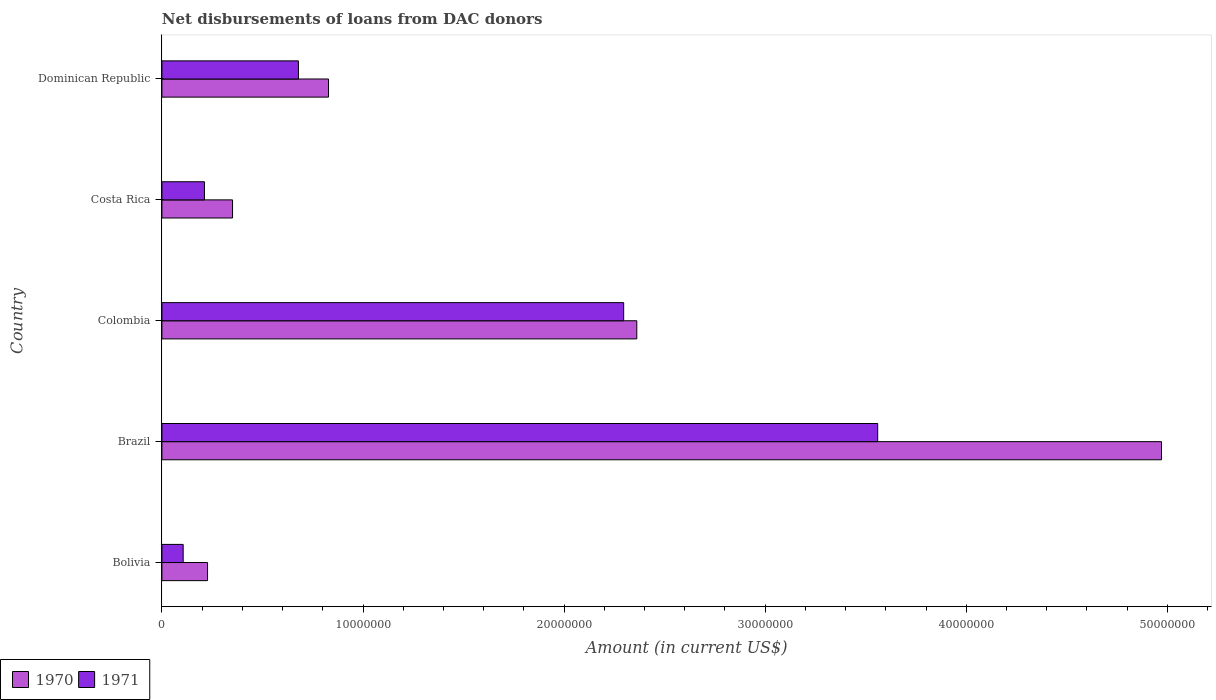How many groups of bars are there?
Give a very brief answer. 5. Are the number of bars per tick equal to the number of legend labels?
Keep it short and to the point. Yes. How many bars are there on the 2nd tick from the bottom?
Give a very brief answer. 2. What is the label of the 5th group of bars from the top?
Provide a succinct answer. Bolivia. What is the amount of loans disbursed in 1970 in Colombia?
Give a very brief answer. 2.36e+07. Across all countries, what is the maximum amount of loans disbursed in 1971?
Give a very brief answer. 3.56e+07. Across all countries, what is the minimum amount of loans disbursed in 1971?
Ensure brevity in your answer.  1.06e+06. In which country was the amount of loans disbursed in 1970 minimum?
Offer a terse response. Bolivia. What is the total amount of loans disbursed in 1971 in the graph?
Offer a very short reply. 6.85e+07. What is the difference between the amount of loans disbursed in 1971 in Brazil and that in Colombia?
Offer a terse response. 1.26e+07. What is the difference between the amount of loans disbursed in 1971 in Costa Rica and the amount of loans disbursed in 1970 in Brazil?
Your answer should be compact. -4.76e+07. What is the average amount of loans disbursed in 1971 per country?
Provide a succinct answer. 1.37e+07. What is the difference between the amount of loans disbursed in 1970 and amount of loans disbursed in 1971 in Colombia?
Keep it short and to the point. 6.52e+05. In how many countries, is the amount of loans disbursed in 1971 greater than 12000000 US$?
Your response must be concise. 2. What is the ratio of the amount of loans disbursed in 1970 in Colombia to that in Dominican Republic?
Keep it short and to the point. 2.85. What is the difference between the highest and the second highest amount of loans disbursed in 1971?
Provide a succinct answer. 1.26e+07. What is the difference between the highest and the lowest amount of loans disbursed in 1971?
Your answer should be very brief. 3.45e+07. What does the 2nd bar from the top in Bolivia represents?
Give a very brief answer. 1970. What is the difference between two consecutive major ticks on the X-axis?
Your response must be concise. 1.00e+07. Are the values on the major ticks of X-axis written in scientific E-notation?
Give a very brief answer. No. Does the graph contain grids?
Provide a succinct answer. No. How are the legend labels stacked?
Your answer should be compact. Horizontal. What is the title of the graph?
Your answer should be compact. Net disbursements of loans from DAC donors. What is the Amount (in current US$) in 1970 in Bolivia?
Provide a short and direct response. 2.27e+06. What is the Amount (in current US$) in 1971 in Bolivia?
Make the answer very short. 1.06e+06. What is the Amount (in current US$) in 1970 in Brazil?
Provide a succinct answer. 4.97e+07. What is the Amount (in current US$) of 1971 in Brazil?
Provide a short and direct response. 3.56e+07. What is the Amount (in current US$) of 1970 in Colombia?
Your answer should be compact. 2.36e+07. What is the Amount (in current US$) in 1971 in Colombia?
Your answer should be compact. 2.30e+07. What is the Amount (in current US$) of 1970 in Costa Rica?
Provide a short and direct response. 3.51e+06. What is the Amount (in current US$) of 1971 in Costa Rica?
Keep it short and to the point. 2.12e+06. What is the Amount (in current US$) in 1970 in Dominican Republic?
Provide a succinct answer. 8.29e+06. What is the Amount (in current US$) of 1971 in Dominican Republic?
Your response must be concise. 6.79e+06. Across all countries, what is the maximum Amount (in current US$) of 1970?
Provide a short and direct response. 4.97e+07. Across all countries, what is the maximum Amount (in current US$) of 1971?
Ensure brevity in your answer.  3.56e+07. Across all countries, what is the minimum Amount (in current US$) in 1970?
Your answer should be very brief. 2.27e+06. Across all countries, what is the minimum Amount (in current US$) of 1971?
Ensure brevity in your answer.  1.06e+06. What is the total Amount (in current US$) of 1970 in the graph?
Make the answer very short. 8.74e+07. What is the total Amount (in current US$) of 1971 in the graph?
Keep it short and to the point. 6.85e+07. What is the difference between the Amount (in current US$) in 1970 in Bolivia and that in Brazil?
Provide a short and direct response. -4.74e+07. What is the difference between the Amount (in current US$) of 1971 in Bolivia and that in Brazil?
Your response must be concise. -3.45e+07. What is the difference between the Amount (in current US$) in 1970 in Bolivia and that in Colombia?
Offer a terse response. -2.13e+07. What is the difference between the Amount (in current US$) in 1971 in Bolivia and that in Colombia?
Keep it short and to the point. -2.19e+07. What is the difference between the Amount (in current US$) in 1970 in Bolivia and that in Costa Rica?
Keep it short and to the point. -1.24e+06. What is the difference between the Amount (in current US$) of 1971 in Bolivia and that in Costa Rica?
Offer a very short reply. -1.06e+06. What is the difference between the Amount (in current US$) of 1970 in Bolivia and that in Dominican Republic?
Offer a terse response. -6.02e+06. What is the difference between the Amount (in current US$) of 1971 in Bolivia and that in Dominican Republic?
Your response must be concise. -5.73e+06. What is the difference between the Amount (in current US$) of 1970 in Brazil and that in Colombia?
Provide a succinct answer. 2.61e+07. What is the difference between the Amount (in current US$) of 1971 in Brazil and that in Colombia?
Provide a short and direct response. 1.26e+07. What is the difference between the Amount (in current US$) of 1970 in Brazil and that in Costa Rica?
Give a very brief answer. 4.62e+07. What is the difference between the Amount (in current US$) in 1971 in Brazil and that in Costa Rica?
Your answer should be very brief. 3.35e+07. What is the difference between the Amount (in current US$) of 1970 in Brazil and that in Dominican Republic?
Give a very brief answer. 4.14e+07. What is the difference between the Amount (in current US$) in 1971 in Brazil and that in Dominican Republic?
Your answer should be very brief. 2.88e+07. What is the difference between the Amount (in current US$) of 1970 in Colombia and that in Costa Rica?
Give a very brief answer. 2.01e+07. What is the difference between the Amount (in current US$) in 1971 in Colombia and that in Costa Rica?
Give a very brief answer. 2.08e+07. What is the difference between the Amount (in current US$) in 1970 in Colombia and that in Dominican Republic?
Your answer should be very brief. 1.53e+07. What is the difference between the Amount (in current US$) in 1971 in Colombia and that in Dominican Republic?
Keep it short and to the point. 1.62e+07. What is the difference between the Amount (in current US$) in 1970 in Costa Rica and that in Dominican Republic?
Give a very brief answer. -4.77e+06. What is the difference between the Amount (in current US$) in 1971 in Costa Rica and that in Dominican Republic?
Offer a very short reply. -4.67e+06. What is the difference between the Amount (in current US$) in 1970 in Bolivia and the Amount (in current US$) in 1971 in Brazil?
Ensure brevity in your answer.  -3.33e+07. What is the difference between the Amount (in current US$) in 1970 in Bolivia and the Amount (in current US$) in 1971 in Colombia?
Make the answer very short. -2.07e+07. What is the difference between the Amount (in current US$) in 1970 in Bolivia and the Amount (in current US$) in 1971 in Costa Rica?
Provide a short and direct response. 1.54e+05. What is the difference between the Amount (in current US$) of 1970 in Bolivia and the Amount (in current US$) of 1971 in Dominican Republic?
Offer a very short reply. -4.52e+06. What is the difference between the Amount (in current US$) of 1970 in Brazil and the Amount (in current US$) of 1971 in Colombia?
Ensure brevity in your answer.  2.67e+07. What is the difference between the Amount (in current US$) of 1970 in Brazil and the Amount (in current US$) of 1971 in Costa Rica?
Give a very brief answer. 4.76e+07. What is the difference between the Amount (in current US$) in 1970 in Brazil and the Amount (in current US$) in 1971 in Dominican Republic?
Give a very brief answer. 4.29e+07. What is the difference between the Amount (in current US$) in 1970 in Colombia and the Amount (in current US$) in 1971 in Costa Rica?
Provide a succinct answer. 2.15e+07. What is the difference between the Amount (in current US$) of 1970 in Colombia and the Amount (in current US$) of 1971 in Dominican Republic?
Offer a terse response. 1.68e+07. What is the difference between the Amount (in current US$) in 1970 in Costa Rica and the Amount (in current US$) in 1971 in Dominican Republic?
Your answer should be very brief. -3.28e+06. What is the average Amount (in current US$) in 1970 per country?
Ensure brevity in your answer.  1.75e+07. What is the average Amount (in current US$) of 1971 per country?
Your answer should be compact. 1.37e+07. What is the difference between the Amount (in current US$) in 1970 and Amount (in current US$) in 1971 in Bolivia?
Offer a terse response. 1.21e+06. What is the difference between the Amount (in current US$) of 1970 and Amount (in current US$) of 1971 in Brazil?
Make the answer very short. 1.41e+07. What is the difference between the Amount (in current US$) of 1970 and Amount (in current US$) of 1971 in Colombia?
Offer a terse response. 6.52e+05. What is the difference between the Amount (in current US$) in 1970 and Amount (in current US$) in 1971 in Costa Rica?
Your answer should be very brief. 1.40e+06. What is the difference between the Amount (in current US$) in 1970 and Amount (in current US$) in 1971 in Dominican Republic?
Keep it short and to the point. 1.50e+06. What is the ratio of the Amount (in current US$) in 1970 in Bolivia to that in Brazil?
Provide a short and direct response. 0.05. What is the ratio of the Amount (in current US$) in 1971 in Bolivia to that in Brazil?
Give a very brief answer. 0.03. What is the ratio of the Amount (in current US$) in 1970 in Bolivia to that in Colombia?
Your answer should be compact. 0.1. What is the ratio of the Amount (in current US$) of 1971 in Bolivia to that in Colombia?
Provide a succinct answer. 0.05. What is the ratio of the Amount (in current US$) of 1970 in Bolivia to that in Costa Rica?
Your answer should be compact. 0.65. What is the ratio of the Amount (in current US$) of 1971 in Bolivia to that in Costa Rica?
Offer a terse response. 0.5. What is the ratio of the Amount (in current US$) of 1970 in Bolivia to that in Dominican Republic?
Provide a succinct answer. 0.27. What is the ratio of the Amount (in current US$) of 1971 in Bolivia to that in Dominican Republic?
Offer a terse response. 0.16. What is the ratio of the Amount (in current US$) in 1970 in Brazil to that in Colombia?
Provide a succinct answer. 2.1. What is the ratio of the Amount (in current US$) of 1971 in Brazil to that in Colombia?
Your response must be concise. 1.55. What is the ratio of the Amount (in current US$) of 1970 in Brazil to that in Costa Rica?
Your answer should be compact. 14.15. What is the ratio of the Amount (in current US$) in 1971 in Brazil to that in Costa Rica?
Your answer should be compact. 16.82. What is the ratio of the Amount (in current US$) of 1970 in Brazil to that in Dominican Republic?
Make the answer very short. 6. What is the ratio of the Amount (in current US$) in 1971 in Brazil to that in Dominican Republic?
Make the answer very short. 5.24. What is the ratio of the Amount (in current US$) in 1970 in Colombia to that in Costa Rica?
Provide a short and direct response. 6.72. What is the ratio of the Amount (in current US$) in 1971 in Colombia to that in Costa Rica?
Your response must be concise. 10.85. What is the ratio of the Amount (in current US$) in 1970 in Colombia to that in Dominican Republic?
Offer a terse response. 2.85. What is the ratio of the Amount (in current US$) in 1971 in Colombia to that in Dominican Republic?
Provide a succinct answer. 3.38. What is the ratio of the Amount (in current US$) of 1970 in Costa Rica to that in Dominican Republic?
Keep it short and to the point. 0.42. What is the ratio of the Amount (in current US$) of 1971 in Costa Rica to that in Dominican Republic?
Offer a terse response. 0.31. What is the difference between the highest and the second highest Amount (in current US$) in 1970?
Ensure brevity in your answer.  2.61e+07. What is the difference between the highest and the second highest Amount (in current US$) in 1971?
Give a very brief answer. 1.26e+07. What is the difference between the highest and the lowest Amount (in current US$) of 1970?
Offer a terse response. 4.74e+07. What is the difference between the highest and the lowest Amount (in current US$) of 1971?
Give a very brief answer. 3.45e+07. 